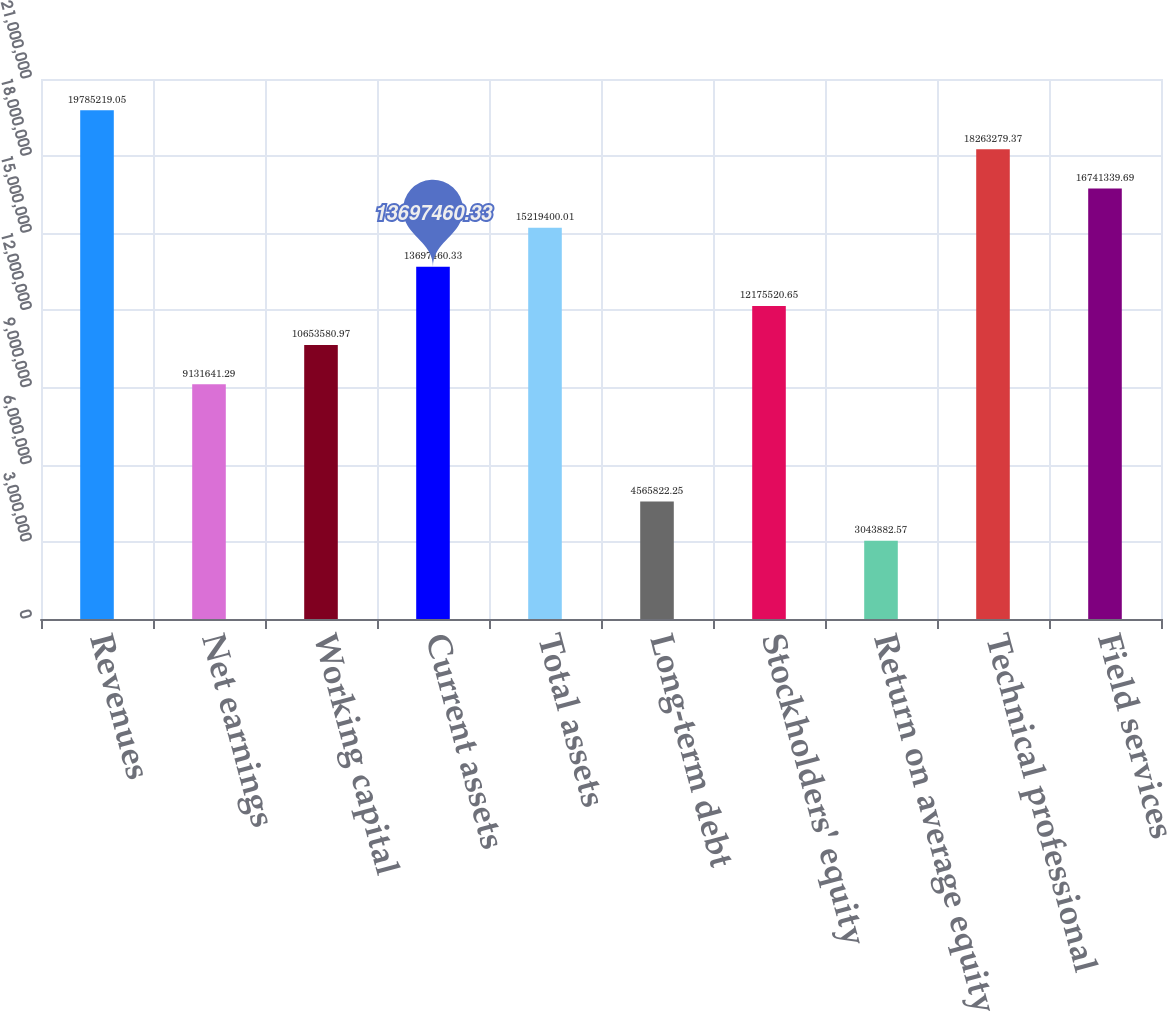Convert chart to OTSL. <chart><loc_0><loc_0><loc_500><loc_500><bar_chart><fcel>Revenues<fcel>Net earnings<fcel>Working capital<fcel>Current assets<fcel>Total assets<fcel>Long-term debt<fcel>Stockholders' equity<fcel>Return on average equity<fcel>Technical professional<fcel>Field services<nl><fcel>1.97852e+07<fcel>9.13164e+06<fcel>1.06536e+07<fcel>1.36975e+07<fcel>1.52194e+07<fcel>4.56582e+06<fcel>1.21755e+07<fcel>3.04388e+06<fcel>1.82633e+07<fcel>1.67413e+07<nl></chart> 